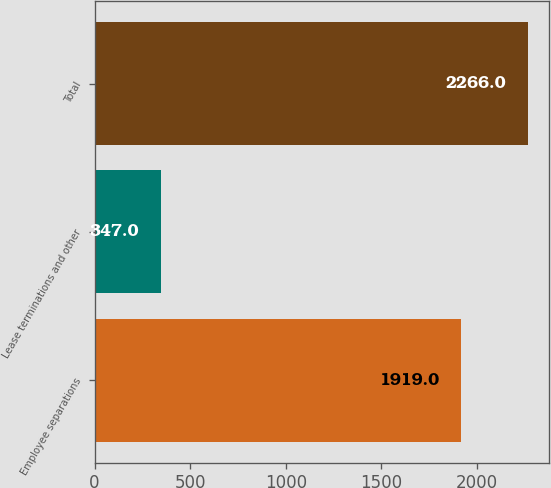Convert chart to OTSL. <chart><loc_0><loc_0><loc_500><loc_500><bar_chart><fcel>Employee separations<fcel>Lease terminations and other<fcel>Total<nl><fcel>1919<fcel>347<fcel>2266<nl></chart> 